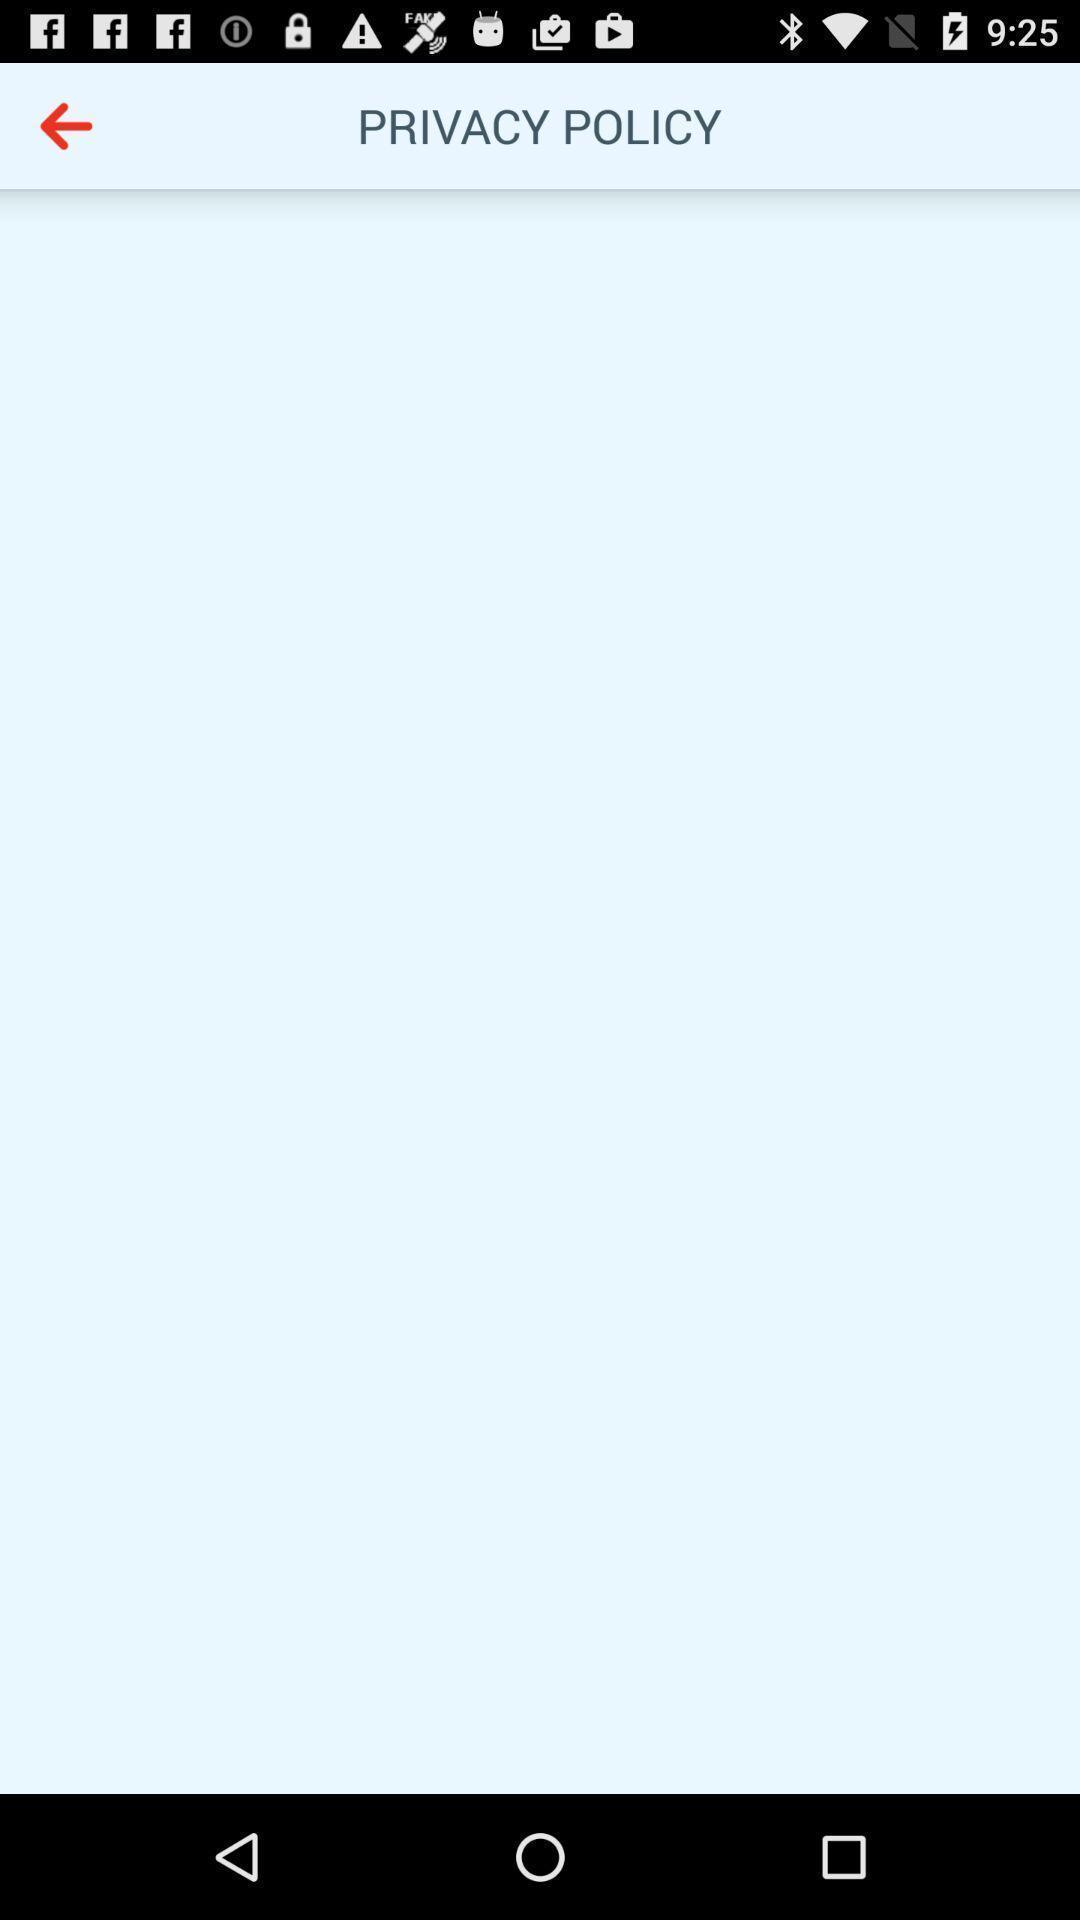Summarize the main components in this picture. Screen shows a blank page of privacy policy. 